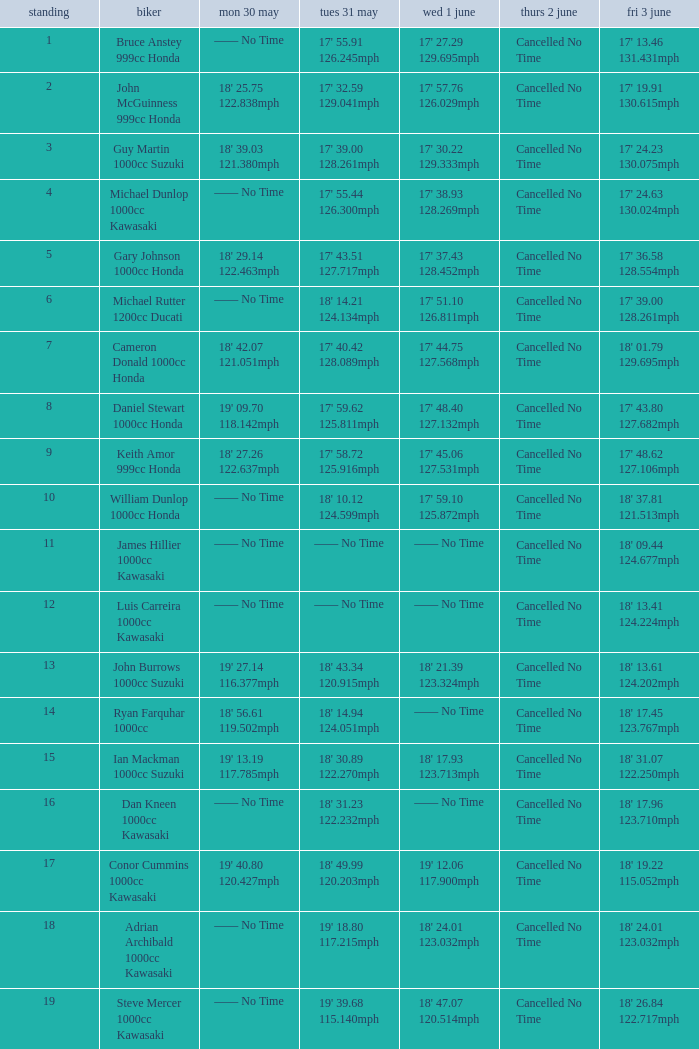What is the Fri 3 June time for the rider whose Tues 31 May time was 19' 18.80 117.215mph? 18' 24.01 123.032mph. 